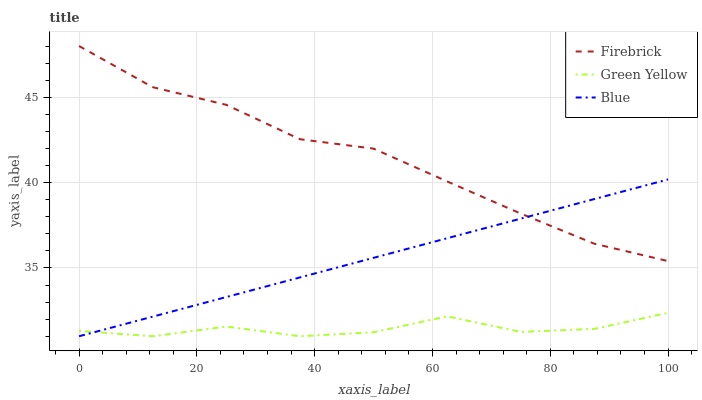Does Green Yellow have the minimum area under the curve?
Answer yes or no. Yes. Does Firebrick have the maximum area under the curve?
Answer yes or no. Yes. Does Firebrick have the minimum area under the curve?
Answer yes or no. No. Does Green Yellow have the maximum area under the curve?
Answer yes or no. No. Is Blue the smoothest?
Answer yes or no. Yes. Is Green Yellow the roughest?
Answer yes or no. Yes. Is Firebrick the smoothest?
Answer yes or no. No. Is Firebrick the roughest?
Answer yes or no. No. Does Blue have the lowest value?
Answer yes or no. Yes. Does Firebrick have the lowest value?
Answer yes or no. No. Does Firebrick have the highest value?
Answer yes or no. Yes. Does Green Yellow have the highest value?
Answer yes or no. No. Is Green Yellow less than Firebrick?
Answer yes or no. Yes. Is Firebrick greater than Green Yellow?
Answer yes or no. Yes. Does Blue intersect Firebrick?
Answer yes or no. Yes. Is Blue less than Firebrick?
Answer yes or no. No. Is Blue greater than Firebrick?
Answer yes or no. No. Does Green Yellow intersect Firebrick?
Answer yes or no. No. 